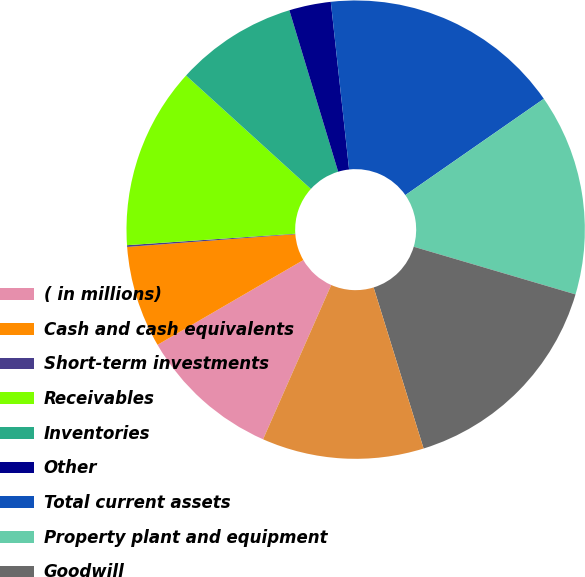Convert chart. <chart><loc_0><loc_0><loc_500><loc_500><pie_chart><fcel>( in millions)<fcel>Cash and cash equivalents<fcel>Short-term investments<fcel>Receivables<fcel>Inventories<fcel>Other<fcel>Total current assets<fcel>Property plant and equipment<fcel>Goodwill<fcel>Identifiable intangible assets<nl><fcel>10.0%<fcel>7.18%<fcel>0.12%<fcel>12.82%<fcel>8.59%<fcel>2.94%<fcel>17.06%<fcel>14.23%<fcel>15.65%<fcel>11.41%<nl></chart> 